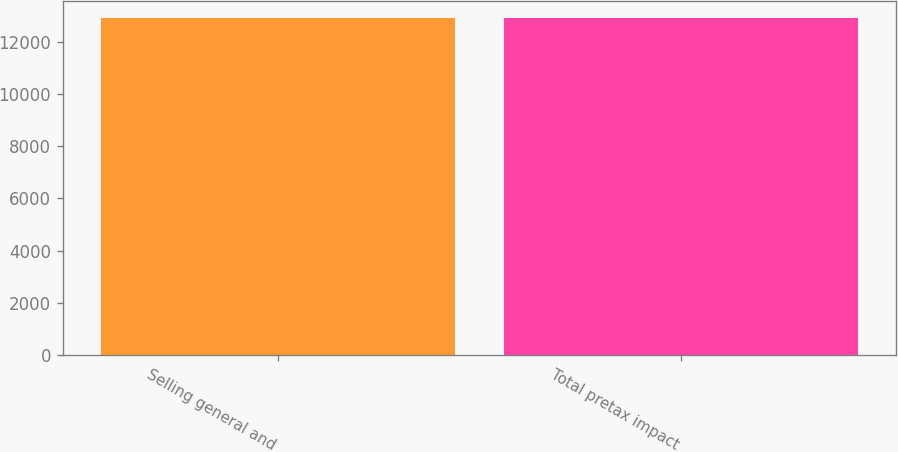Convert chart. <chart><loc_0><loc_0><loc_500><loc_500><bar_chart><fcel>Selling general and<fcel>Total pretax impact<nl><fcel>12908<fcel>12908.1<nl></chart> 